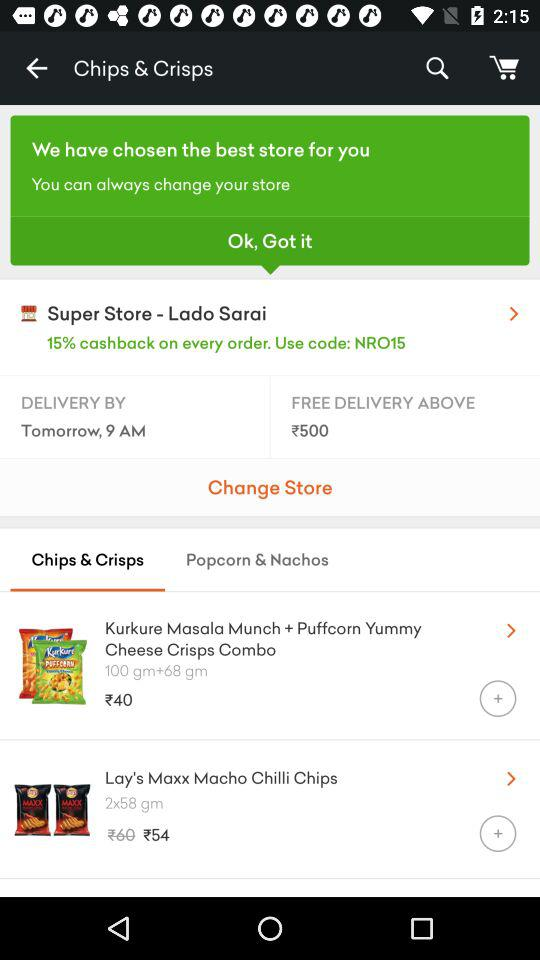How much do you get in cashback on every order? You get 15% cashback on every order. 